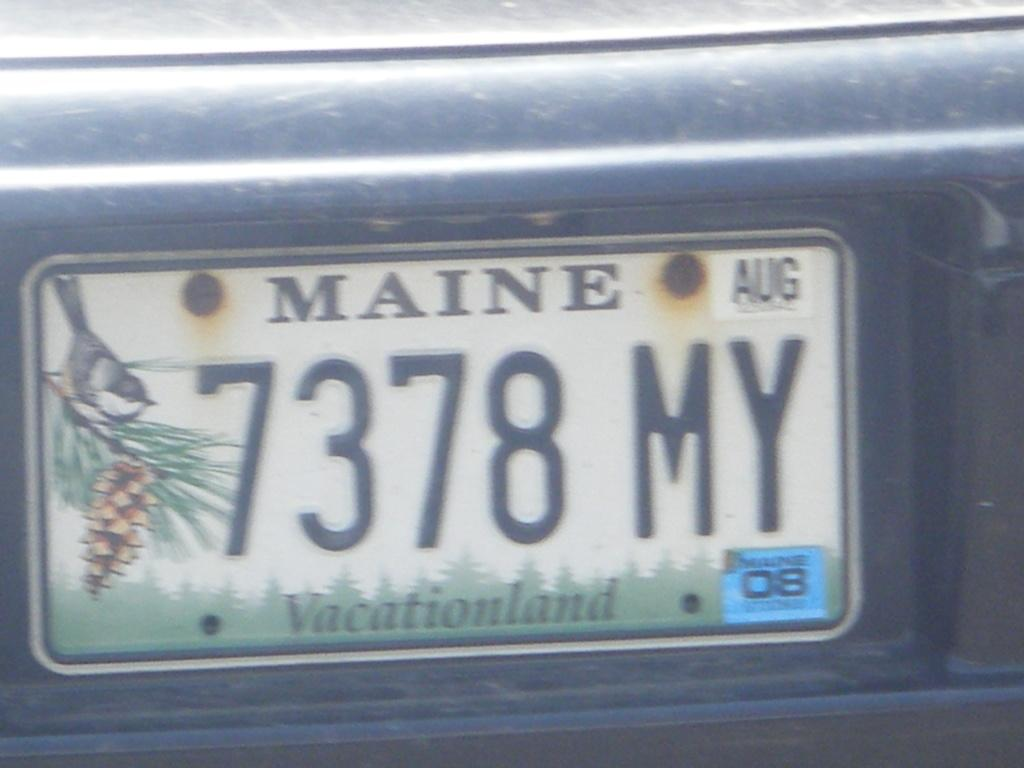<image>
Share a concise interpretation of the image provided. A Maine license plate states "7378 MY Vacationland." 